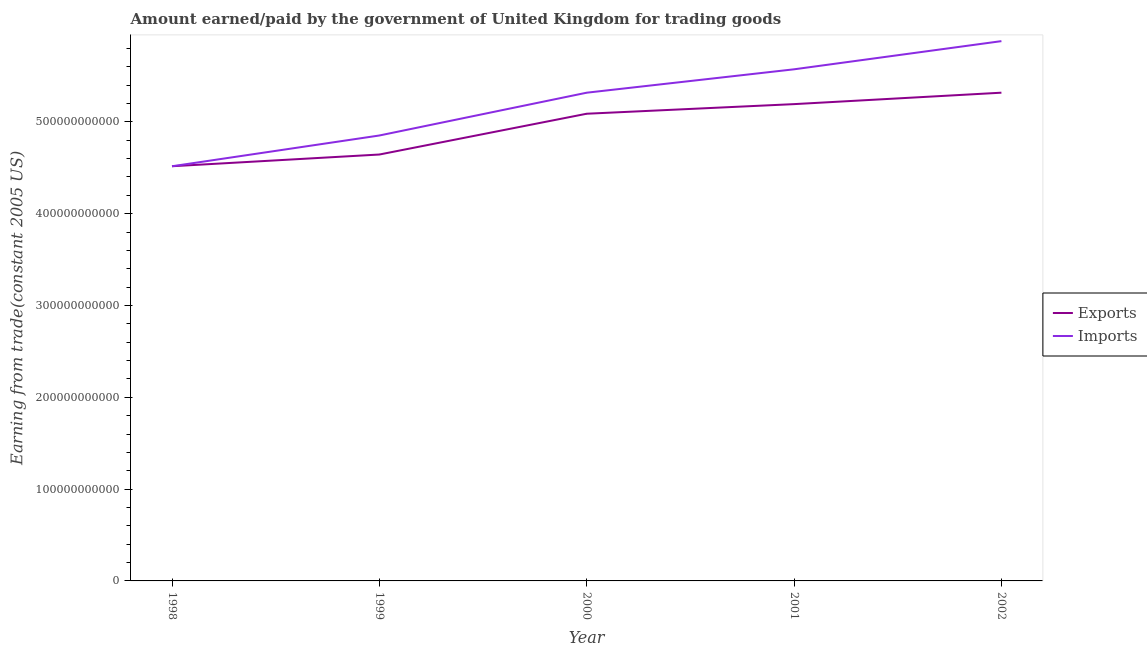How many different coloured lines are there?
Keep it short and to the point. 2. Does the line corresponding to amount earned from exports intersect with the line corresponding to amount paid for imports?
Your response must be concise. Yes. Is the number of lines equal to the number of legend labels?
Offer a terse response. Yes. What is the amount earned from exports in 2002?
Offer a terse response. 5.32e+11. Across all years, what is the maximum amount paid for imports?
Give a very brief answer. 5.88e+11. Across all years, what is the minimum amount paid for imports?
Ensure brevity in your answer.  4.52e+11. In which year was the amount earned from exports maximum?
Provide a short and direct response. 2002. In which year was the amount earned from exports minimum?
Your answer should be compact. 1998. What is the total amount paid for imports in the graph?
Your response must be concise. 2.61e+12. What is the difference between the amount earned from exports in 1998 and that in 2000?
Your answer should be compact. -5.72e+1. What is the difference between the amount earned from exports in 1998 and the amount paid for imports in 2000?
Provide a succinct answer. -8.01e+1. What is the average amount earned from exports per year?
Your response must be concise. 4.95e+11. In the year 1998, what is the difference between the amount paid for imports and amount earned from exports?
Offer a very short reply. -2.20e+07. What is the ratio of the amount paid for imports in 1998 to that in 2000?
Ensure brevity in your answer.  0.85. Is the amount earned from exports in 1999 less than that in 2000?
Your response must be concise. Yes. Is the difference between the amount earned from exports in 1999 and 2001 greater than the difference between the amount paid for imports in 1999 and 2001?
Your response must be concise. Yes. What is the difference between the highest and the second highest amount paid for imports?
Provide a short and direct response. 3.07e+1. What is the difference between the highest and the lowest amount paid for imports?
Make the answer very short. 1.36e+11. In how many years, is the amount paid for imports greater than the average amount paid for imports taken over all years?
Offer a very short reply. 3. Does the amount earned from exports monotonically increase over the years?
Keep it short and to the point. Yes. Is the amount paid for imports strictly less than the amount earned from exports over the years?
Give a very brief answer. No. How many lines are there?
Provide a short and direct response. 2. How many years are there in the graph?
Your answer should be compact. 5. What is the difference between two consecutive major ticks on the Y-axis?
Ensure brevity in your answer.  1.00e+11. Does the graph contain any zero values?
Your answer should be very brief. No. Where does the legend appear in the graph?
Your answer should be compact. Center right. How many legend labels are there?
Your response must be concise. 2. What is the title of the graph?
Provide a succinct answer. Amount earned/paid by the government of United Kingdom for trading goods. Does "Register a property" appear as one of the legend labels in the graph?
Make the answer very short. No. What is the label or title of the X-axis?
Offer a very short reply. Year. What is the label or title of the Y-axis?
Offer a terse response. Earning from trade(constant 2005 US). What is the Earning from trade(constant 2005 US) of Exports in 1998?
Make the answer very short. 4.52e+11. What is the Earning from trade(constant 2005 US) in Imports in 1998?
Your answer should be very brief. 4.52e+11. What is the Earning from trade(constant 2005 US) in Exports in 1999?
Provide a short and direct response. 4.64e+11. What is the Earning from trade(constant 2005 US) of Imports in 1999?
Give a very brief answer. 4.85e+11. What is the Earning from trade(constant 2005 US) in Exports in 2000?
Your answer should be very brief. 5.09e+11. What is the Earning from trade(constant 2005 US) of Imports in 2000?
Make the answer very short. 5.32e+11. What is the Earning from trade(constant 2005 US) of Exports in 2001?
Make the answer very short. 5.19e+11. What is the Earning from trade(constant 2005 US) in Imports in 2001?
Keep it short and to the point. 5.57e+11. What is the Earning from trade(constant 2005 US) of Exports in 2002?
Your answer should be compact. 5.32e+11. What is the Earning from trade(constant 2005 US) in Imports in 2002?
Offer a very short reply. 5.88e+11. Across all years, what is the maximum Earning from trade(constant 2005 US) of Exports?
Make the answer very short. 5.32e+11. Across all years, what is the maximum Earning from trade(constant 2005 US) of Imports?
Keep it short and to the point. 5.88e+11. Across all years, what is the minimum Earning from trade(constant 2005 US) in Exports?
Ensure brevity in your answer.  4.52e+11. Across all years, what is the minimum Earning from trade(constant 2005 US) of Imports?
Offer a very short reply. 4.52e+11. What is the total Earning from trade(constant 2005 US) of Exports in the graph?
Your answer should be compact. 2.48e+12. What is the total Earning from trade(constant 2005 US) of Imports in the graph?
Your answer should be very brief. 2.61e+12. What is the difference between the Earning from trade(constant 2005 US) of Exports in 1998 and that in 1999?
Your answer should be very brief. -1.28e+1. What is the difference between the Earning from trade(constant 2005 US) of Imports in 1998 and that in 1999?
Your response must be concise. -3.35e+1. What is the difference between the Earning from trade(constant 2005 US) of Exports in 1998 and that in 2000?
Give a very brief answer. -5.72e+1. What is the difference between the Earning from trade(constant 2005 US) in Imports in 1998 and that in 2000?
Offer a very short reply. -8.01e+1. What is the difference between the Earning from trade(constant 2005 US) of Exports in 1998 and that in 2001?
Your answer should be very brief. -6.77e+1. What is the difference between the Earning from trade(constant 2005 US) in Imports in 1998 and that in 2001?
Your answer should be compact. -1.06e+11. What is the difference between the Earning from trade(constant 2005 US) in Exports in 1998 and that in 2002?
Make the answer very short. -8.01e+1. What is the difference between the Earning from trade(constant 2005 US) of Imports in 1998 and that in 2002?
Give a very brief answer. -1.36e+11. What is the difference between the Earning from trade(constant 2005 US) of Exports in 1999 and that in 2000?
Your answer should be compact. -4.44e+1. What is the difference between the Earning from trade(constant 2005 US) of Imports in 1999 and that in 2000?
Give a very brief answer. -4.66e+1. What is the difference between the Earning from trade(constant 2005 US) of Exports in 1999 and that in 2001?
Offer a terse response. -5.49e+1. What is the difference between the Earning from trade(constant 2005 US) in Imports in 1999 and that in 2001?
Provide a succinct answer. -7.21e+1. What is the difference between the Earning from trade(constant 2005 US) of Exports in 1999 and that in 2002?
Keep it short and to the point. -6.74e+1. What is the difference between the Earning from trade(constant 2005 US) in Imports in 1999 and that in 2002?
Provide a succinct answer. -1.03e+11. What is the difference between the Earning from trade(constant 2005 US) in Exports in 2000 and that in 2001?
Your response must be concise. -1.05e+1. What is the difference between the Earning from trade(constant 2005 US) of Imports in 2000 and that in 2001?
Provide a succinct answer. -2.55e+1. What is the difference between the Earning from trade(constant 2005 US) in Exports in 2000 and that in 2002?
Ensure brevity in your answer.  -2.29e+1. What is the difference between the Earning from trade(constant 2005 US) in Imports in 2000 and that in 2002?
Provide a short and direct response. -5.62e+1. What is the difference between the Earning from trade(constant 2005 US) in Exports in 2001 and that in 2002?
Keep it short and to the point. -1.25e+1. What is the difference between the Earning from trade(constant 2005 US) in Imports in 2001 and that in 2002?
Your response must be concise. -3.07e+1. What is the difference between the Earning from trade(constant 2005 US) of Exports in 1998 and the Earning from trade(constant 2005 US) of Imports in 1999?
Make the answer very short. -3.35e+1. What is the difference between the Earning from trade(constant 2005 US) in Exports in 1998 and the Earning from trade(constant 2005 US) in Imports in 2000?
Make the answer very short. -8.01e+1. What is the difference between the Earning from trade(constant 2005 US) in Exports in 1998 and the Earning from trade(constant 2005 US) in Imports in 2001?
Your answer should be compact. -1.06e+11. What is the difference between the Earning from trade(constant 2005 US) of Exports in 1998 and the Earning from trade(constant 2005 US) of Imports in 2002?
Offer a terse response. -1.36e+11. What is the difference between the Earning from trade(constant 2005 US) in Exports in 1999 and the Earning from trade(constant 2005 US) in Imports in 2000?
Your answer should be very brief. -6.73e+1. What is the difference between the Earning from trade(constant 2005 US) of Exports in 1999 and the Earning from trade(constant 2005 US) of Imports in 2001?
Your answer should be very brief. -9.28e+1. What is the difference between the Earning from trade(constant 2005 US) of Exports in 1999 and the Earning from trade(constant 2005 US) of Imports in 2002?
Your answer should be very brief. -1.24e+11. What is the difference between the Earning from trade(constant 2005 US) of Exports in 2000 and the Earning from trade(constant 2005 US) of Imports in 2001?
Your answer should be very brief. -4.84e+1. What is the difference between the Earning from trade(constant 2005 US) in Exports in 2000 and the Earning from trade(constant 2005 US) in Imports in 2002?
Make the answer very short. -7.91e+1. What is the difference between the Earning from trade(constant 2005 US) in Exports in 2001 and the Earning from trade(constant 2005 US) in Imports in 2002?
Offer a terse response. -6.86e+1. What is the average Earning from trade(constant 2005 US) of Exports per year?
Provide a succinct answer. 4.95e+11. What is the average Earning from trade(constant 2005 US) in Imports per year?
Keep it short and to the point. 5.23e+11. In the year 1998, what is the difference between the Earning from trade(constant 2005 US) in Exports and Earning from trade(constant 2005 US) in Imports?
Provide a succinct answer. 2.20e+07. In the year 1999, what is the difference between the Earning from trade(constant 2005 US) in Exports and Earning from trade(constant 2005 US) in Imports?
Keep it short and to the point. -2.07e+1. In the year 2000, what is the difference between the Earning from trade(constant 2005 US) of Exports and Earning from trade(constant 2005 US) of Imports?
Provide a short and direct response. -2.29e+1. In the year 2001, what is the difference between the Earning from trade(constant 2005 US) in Exports and Earning from trade(constant 2005 US) in Imports?
Make the answer very short. -3.79e+1. In the year 2002, what is the difference between the Earning from trade(constant 2005 US) of Exports and Earning from trade(constant 2005 US) of Imports?
Offer a terse response. -5.62e+1. What is the ratio of the Earning from trade(constant 2005 US) in Exports in 1998 to that in 1999?
Ensure brevity in your answer.  0.97. What is the ratio of the Earning from trade(constant 2005 US) in Imports in 1998 to that in 1999?
Give a very brief answer. 0.93. What is the ratio of the Earning from trade(constant 2005 US) in Exports in 1998 to that in 2000?
Provide a succinct answer. 0.89. What is the ratio of the Earning from trade(constant 2005 US) of Imports in 1998 to that in 2000?
Your answer should be very brief. 0.85. What is the ratio of the Earning from trade(constant 2005 US) in Exports in 1998 to that in 2001?
Ensure brevity in your answer.  0.87. What is the ratio of the Earning from trade(constant 2005 US) of Imports in 1998 to that in 2001?
Make the answer very short. 0.81. What is the ratio of the Earning from trade(constant 2005 US) of Exports in 1998 to that in 2002?
Ensure brevity in your answer.  0.85. What is the ratio of the Earning from trade(constant 2005 US) of Imports in 1998 to that in 2002?
Your answer should be compact. 0.77. What is the ratio of the Earning from trade(constant 2005 US) of Exports in 1999 to that in 2000?
Ensure brevity in your answer.  0.91. What is the ratio of the Earning from trade(constant 2005 US) in Imports in 1999 to that in 2000?
Provide a short and direct response. 0.91. What is the ratio of the Earning from trade(constant 2005 US) in Exports in 1999 to that in 2001?
Give a very brief answer. 0.89. What is the ratio of the Earning from trade(constant 2005 US) of Imports in 1999 to that in 2001?
Your answer should be compact. 0.87. What is the ratio of the Earning from trade(constant 2005 US) in Exports in 1999 to that in 2002?
Keep it short and to the point. 0.87. What is the ratio of the Earning from trade(constant 2005 US) in Imports in 1999 to that in 2002?
Offer a very short reply. 0.83. What is the ratio of the Earning from trade(constant 2005 US) in Exports in 2000 to that in 2001?
Offer a terse response. 0.98. What is the ratio of the Earning from trade(constant 2005 US) of Imports in 2000 to that in 2001?
Offer a very short reply. 0.95. What is the ratio of the Earning from trade(constant 2005 US) of Exports in 2000 to that in 2002?
Provide a short and direct response. 0.96. What is the ratio of the Earning from trade(constant 2005 US) in Imports in 2000 to that in 2002?
Offer a very short reply. 0.9. What is the ratio of the Earning from trade(constant 2005 US) of Exports in 2001 to that in 2002?
Make the answer very short. 0.98. What is the ratio of the Earning from trade(constant 2005 US) in Imports in 2001 to that in 2002?
Keep it short and to the point. 0.95. What is the difference between the highest and the second highest Earning from trade(constant 2005 US) of Exports?
Provide a succinct answer. 1.25e+1. What is the difference between the highest and the second highest Earning from trade(constant 2005 US) of Imports?
Your response must be concise. 3.07e+1. What is the difference between the highest and the lowest Earning from trade(constant 2005 US) in Exports?
Your answer should be compact. 8.01e+1. What is the difference between the highest and the lowest Earning from trade(constant 2005 US) in Imports?
Your answer should be compact. 1.36e+11. 